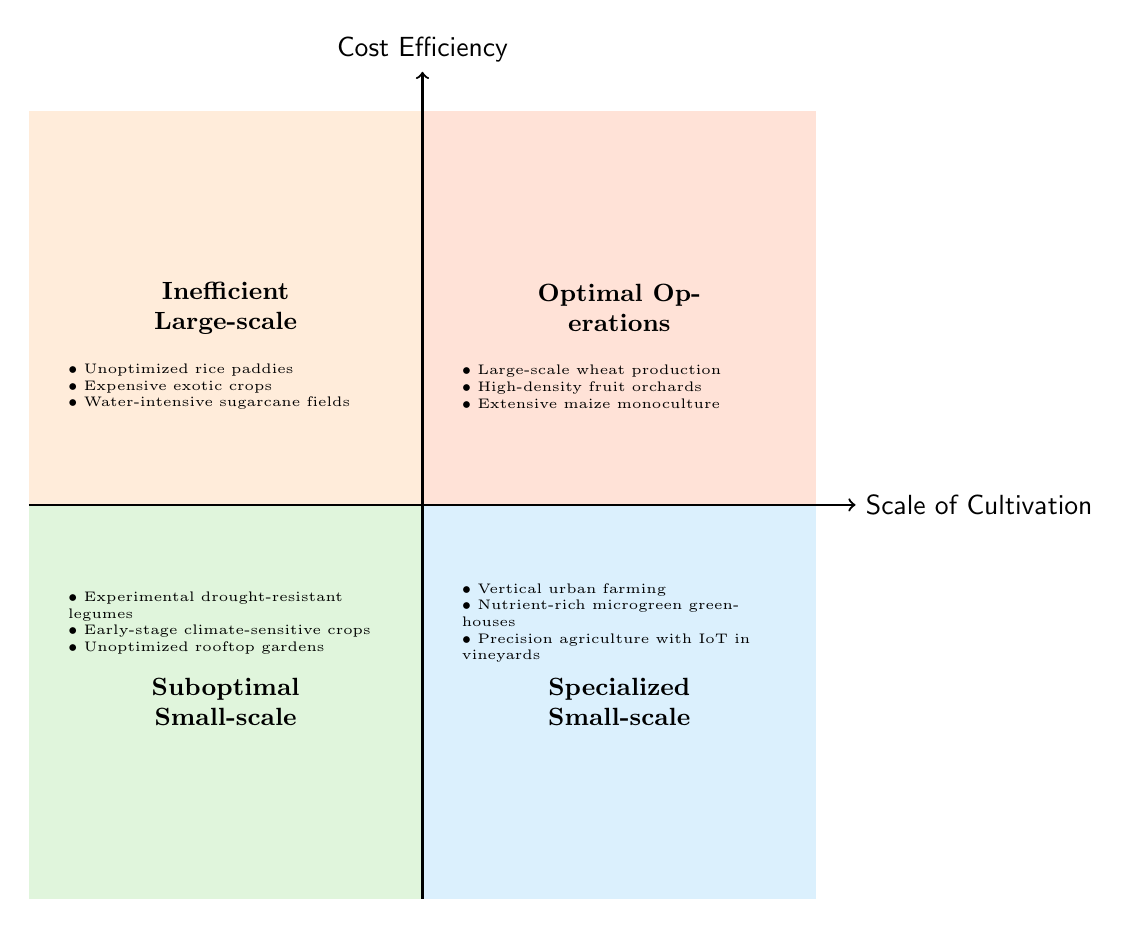What are the elements in the "Optimal Operations" quadrant? The "Optimal Operations" quadrant is located in the upper-right area of the diagram, labeled as such. The elements listed within this quadrant include "Large-scale wheat production," "High-density fruit orchards," and "Extensive maize monoculture."
Answer: Large-scale wheat production, High-density fruit orchards, Extensive maize monoculture Which quadrant contains "Vertical urban farming"? "Vertical urban farming" is located in the lower-right quadrant, labeled "Specialized Small-scale." This area represents high cost efficiency combined with low scale of cultivation.
Answer: Specialized Small-scale How many elements are in the "Inefficient Large-scale" quadrant? The "Inefficient Large-scale" quadrant, which is in the upper-left section of the diagram, includes three elements. These elements are listed as follows: "Unoptimized rice paddies," "Expensive exotic crops," and "Water-intensive sugarcane fields."
Answer: 3 What represents low scale and high cost efficiency? The quadrant representing low scale and high cost efficiency is labeled "Specialized Small-scale." The elements in this quadrant emphasize specialized approaches that yield high efficiency despite their smaller size.
Answer: Specialized Small-scale Are there any crops that perform well in both scale and efficiency? Yes, the "Optimal Operations" quadrant illustrates crops that excel in both scale and cost efficiency. This quadrant is characterized by examples such as "Large-scale wheat production," "High-density fruit orchards," and "Extensive maize monoculture."
Answer: Yes 